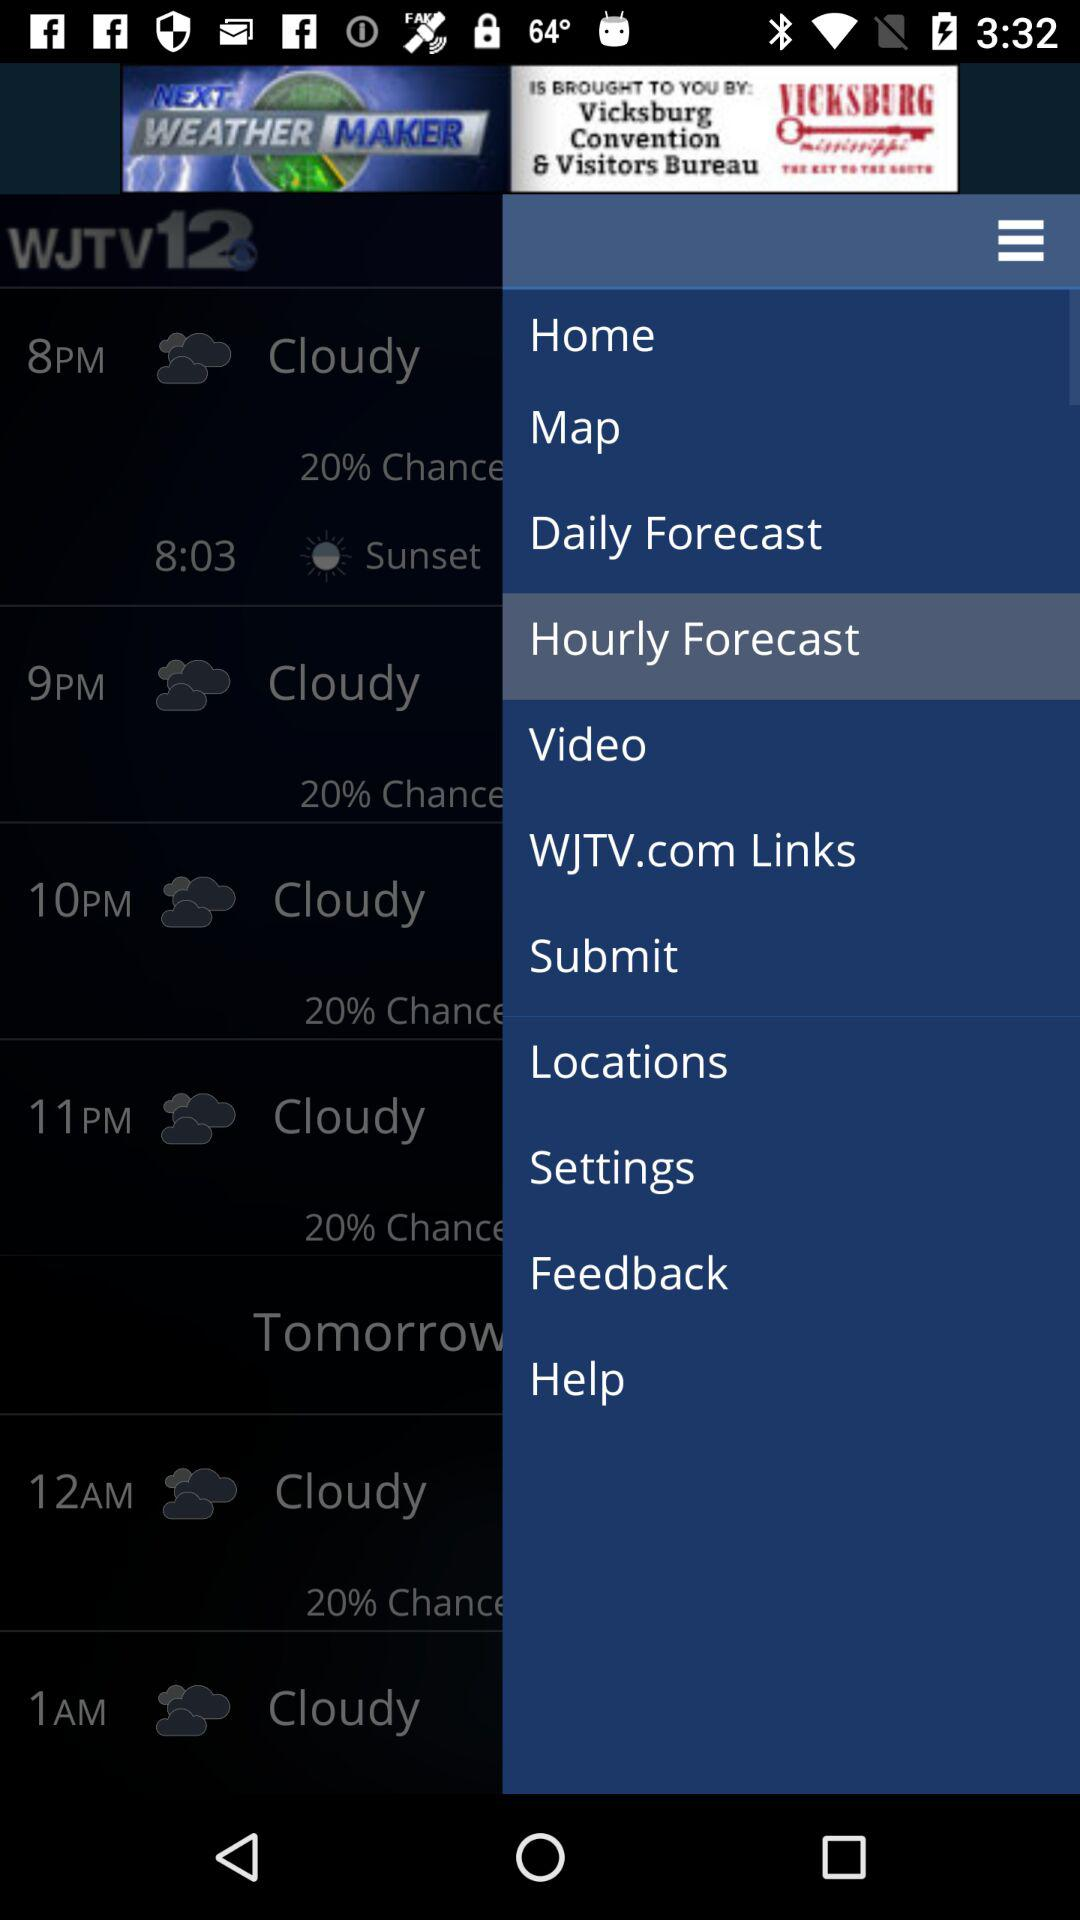What is the percentage chance of rain for tomorrow?
Answer the question using a single word or phrase. 20% 